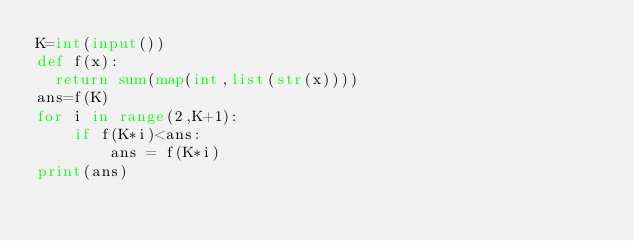Convert code to text. <code><loc_0><loc_0><loc_500><loc_500><_Python_>K=int(input())
def f(x):
  return sum(map(int,list(str(x))))
ans=f(K)
for i in range(2,K+1):
    if f(K*i)<ans:
        ans = f(K*i)
print(ans)</code> 